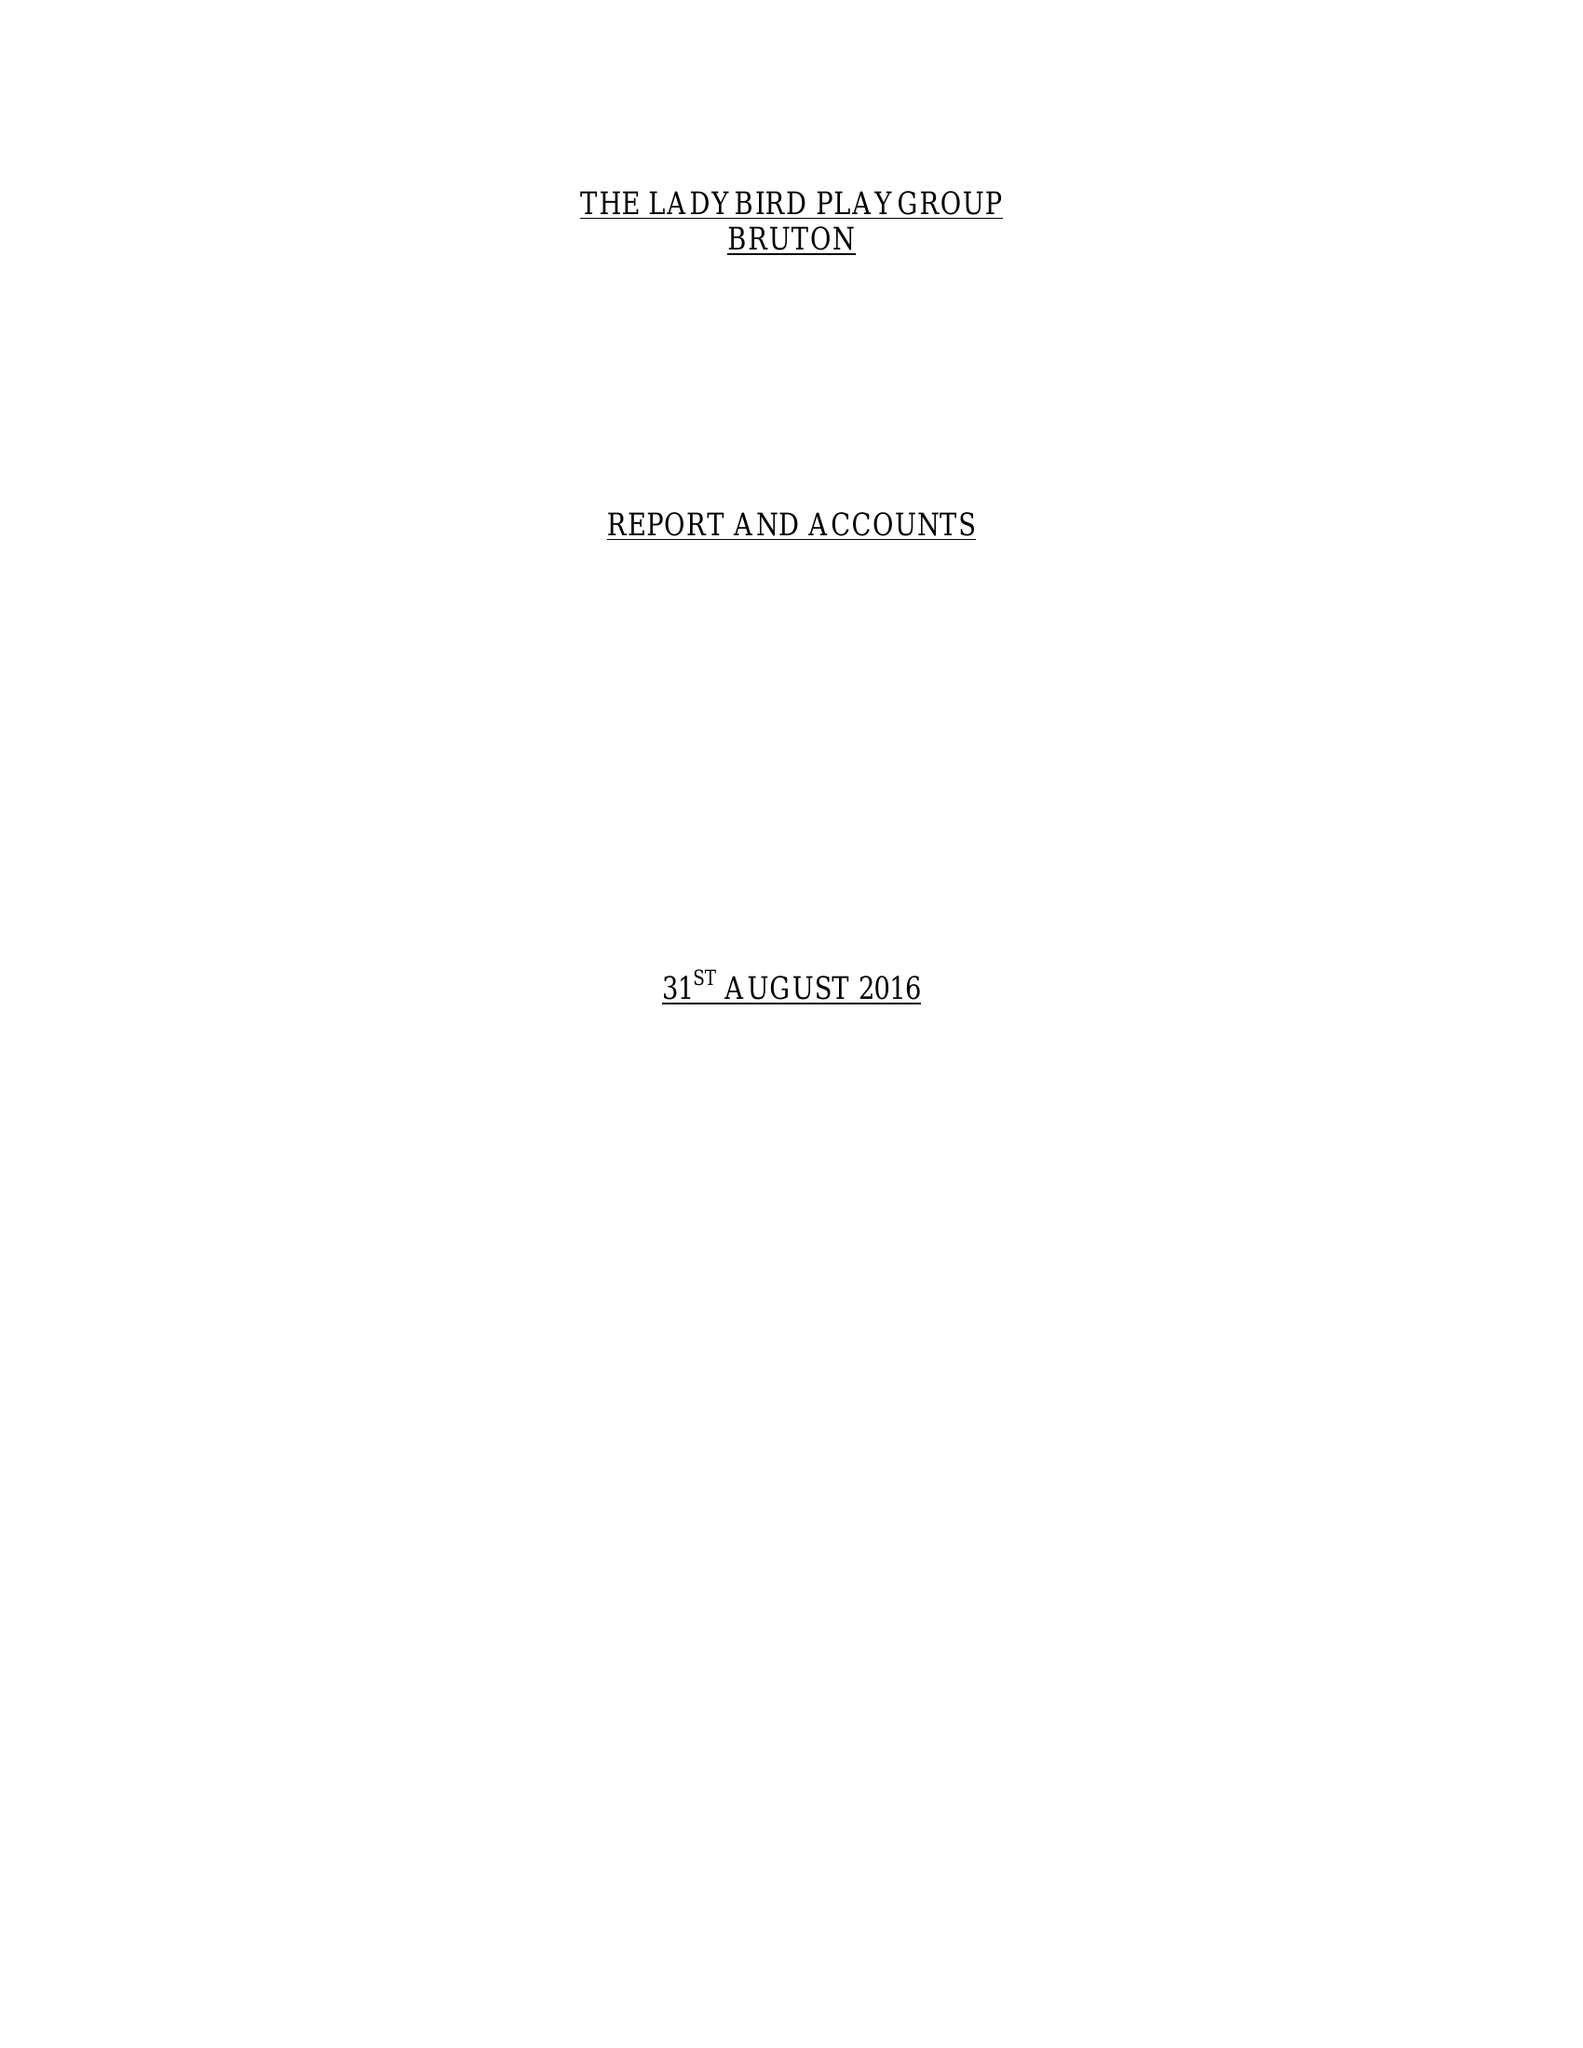What is the value for the charity_name?
Answer the question using a single word or phrase. Ladybird Playgroup 